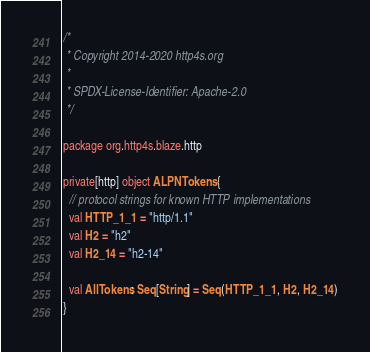Convert code to text. <code><loc_0><loc_0><loc_500><loc_500><_Scala_>/*
 * Copyright 2014-2020 http4s.org
 *
 * SPDX-License-Identifier: Apache-2.0
 */

package org.http4s.blaze.http

private[http] object ALPNTokens {
  // protocol strings for known HTTP implementations
  val HTTP_1_1 = "http/1.1"
  val H2 = "h2"
  val H2_14 = "h2-14"

  val AllTokens: Seq[String] = Seq(HTTP_1_1, H2, H2_14)
}
</code> 